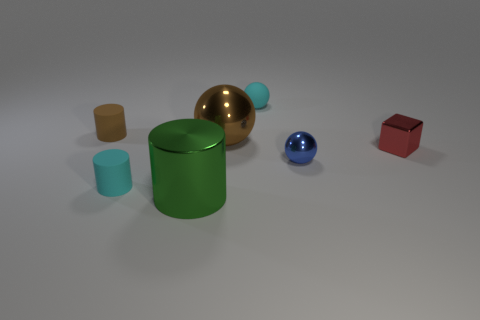Add 2 cyan things. How many objects exist? 9 Subtract all balls. How many objects are left? 4 Add 3 small matte cylinders. How many small matte cylinders are left? 5 Add 3 big cylinders. How many big cylinders exist? 4 Subtract 0 gray blocks. How many objects are left? 7 Subtract all tiny cyan matte things. Subtract all small blue objects. How many objects are left? 4 